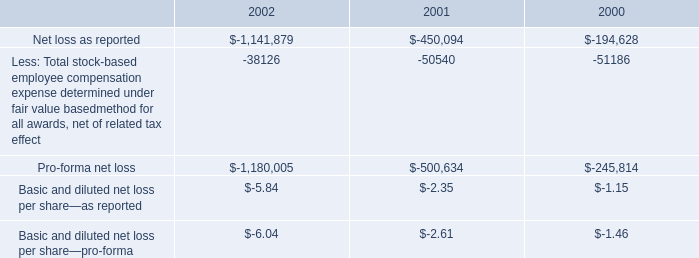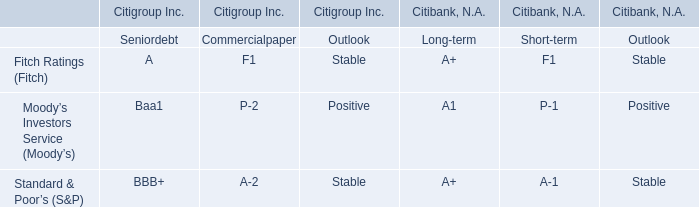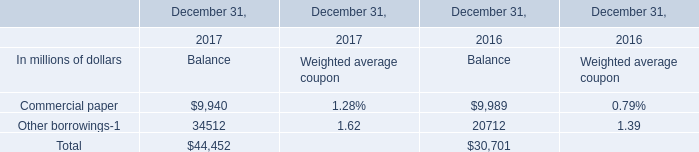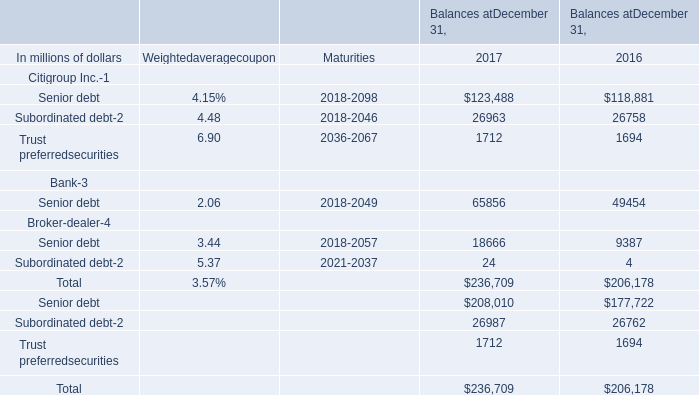In the year with the most Senior debt for Bank, what is the growth rate of Senior debt for Broker-dealer? 
Computations: ((18666 - 9387) / 9387)
Answer: 0.98849. Which year is Senior debt for Bank the most? 
Answer: 2017. 